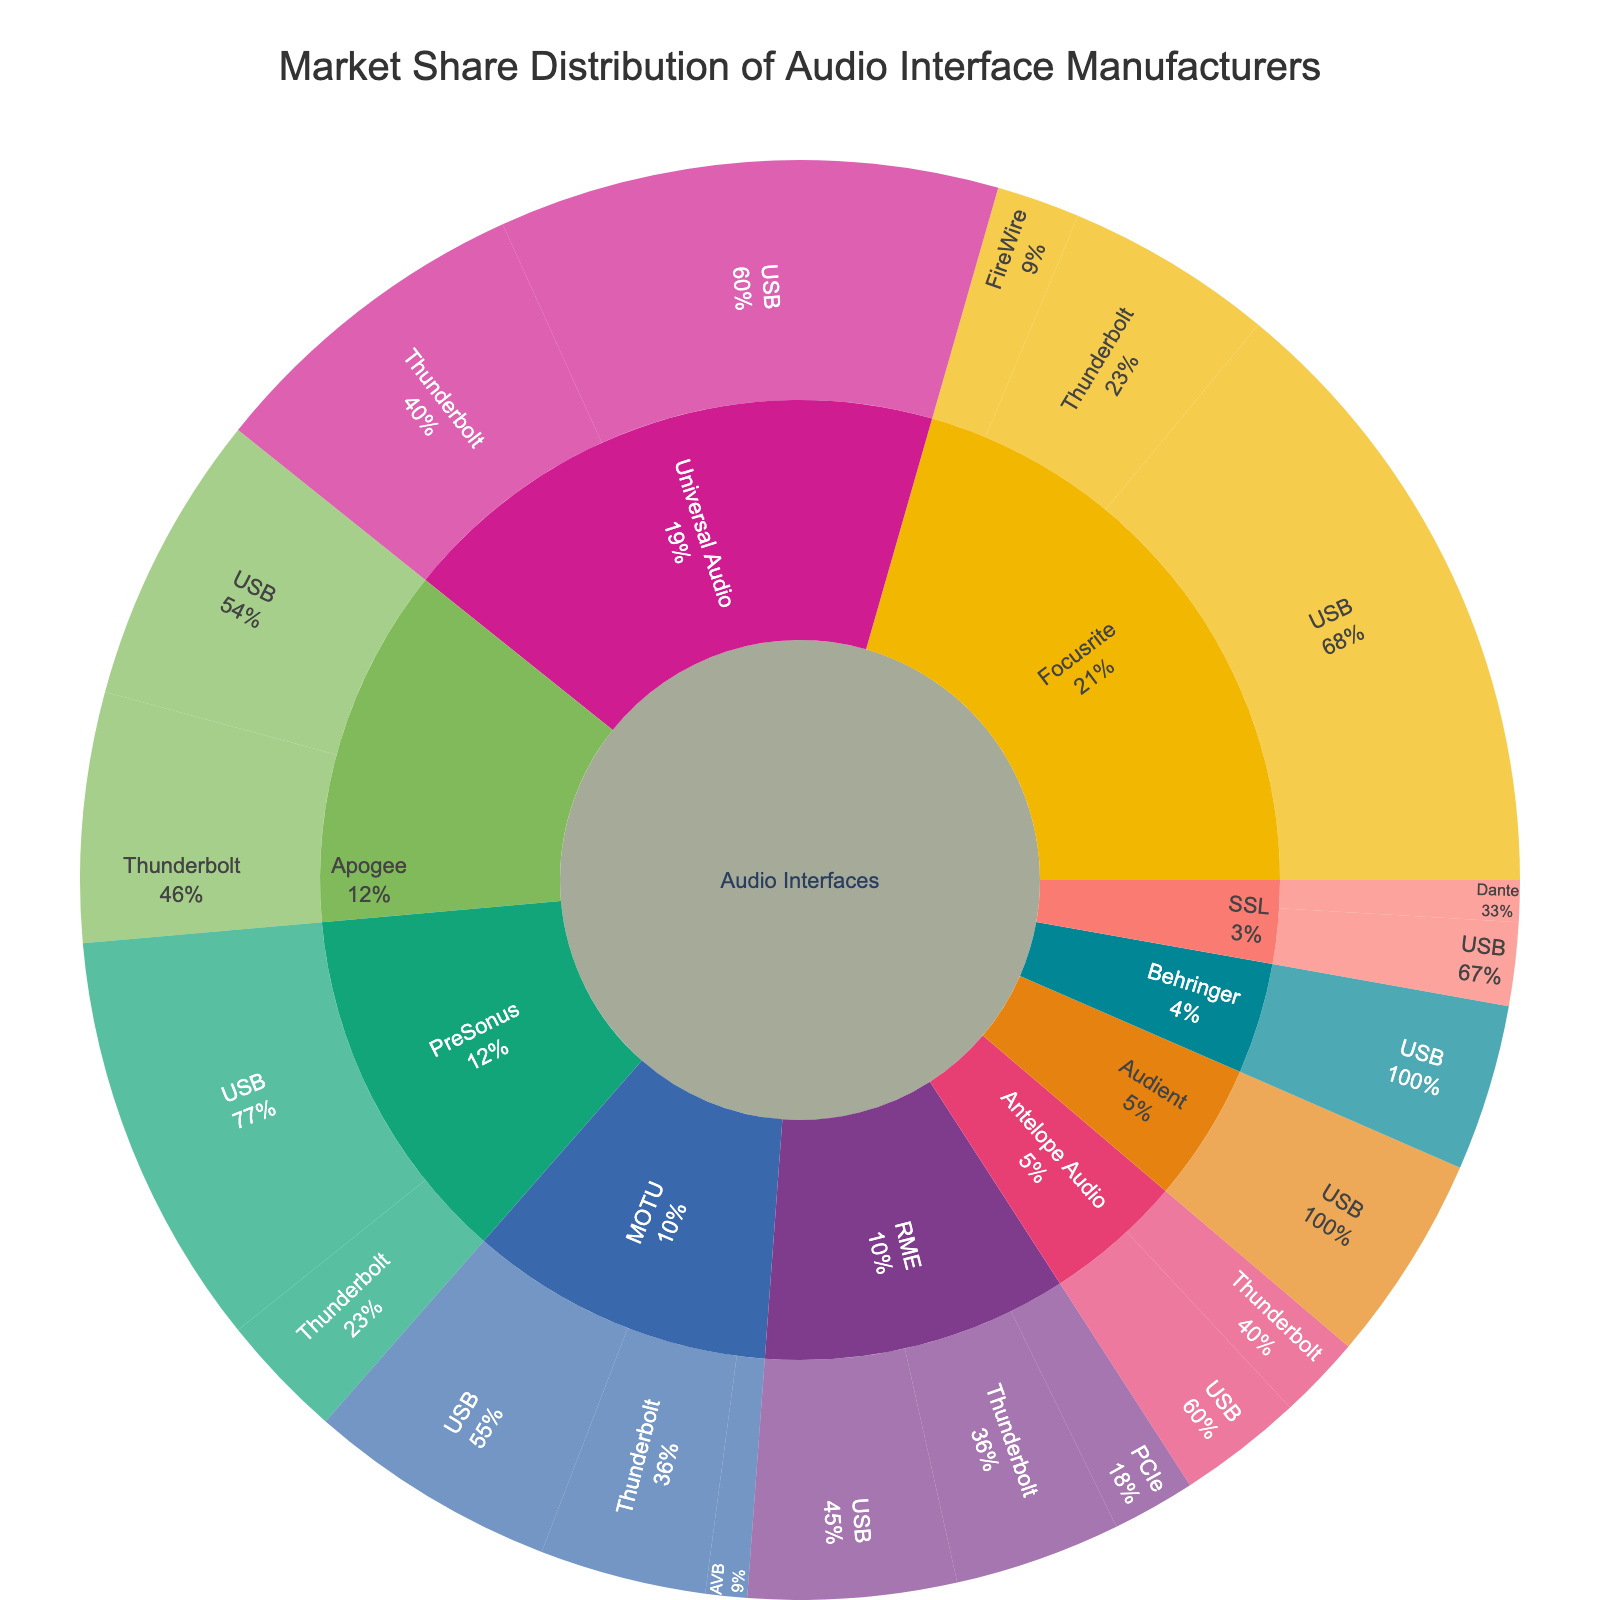What is the total market share for Universal Audio? Sum the market share values for Universal Audio across all connectivity types (USB and Thunderbolt): 12 + 8 = 20
Answer: 20 Which manufacturer has the highest market share for USB connectivity? Compare the market share values for USB connectivity across all manufacturers: Focusrite (15), Universal Audio (12), PreSonus (10), Apogee (7), RME (5), MOTU (6), Audient (5), Behringer (4), Antelope Audio (3), SSL (2). Focusrite has the highest value (15)
Answer: Focusrite How much more market share does Focusrite have with USB compared to Universal Audio's USB? Subtract the market share of Universal Audio (12) from Focusrite's market share (15) for USB: 15 - 12 = 3
Answer: 3 Which connectivity type has the lowest market share for MOTU? Compare the market share values for MOTU across all connectivity types (USB, Thunderbolt, AVB): AVB (1), Thunderbolt (4), USB (6). AVB has the lowest value (1)
Answer: AVB How does the market share of PreSonus with Thunderbolt compare to Apogee with USB? Compare the market share values: PreSonus with Thunderbolt (3) and Apogee with USB (7). Apogee with USB has a higher market share (7 versus 3)
Answer: Apogee with USB is higher What is the combined market share of RME for all its connectivity types? Sum the market share values for RME across all connectivity types (USB, Thunderbolt, PCIe): 5 + 4 + 2 = 11
Answer: 11 Which manufacturer has the least market share overall? Compare the total market share values for all manufacturers by summing their connectivity types, then identify the one with the smallest total:
- SSL: USB (2) + Dante (1) = 3
- Antelope Audio: USB (3) + Thunderbolt (2) = 5
- Behringer: USB (4)
- Audient: USB (5)
- MOTU: USB (6) + Thunderbolt (4) + AVB (1) = 11
- RME: USB (5) + Thunderbolt (4) + PCIe (2) = 11
- Apogee: USB (7) + Thunderbolt (6) = 13
- PreSonus: USB (10) + Thunderbolt (3) = 13
- Focusrite: USB (15) + Thunderbolt (5) + FireWire (2) = 22
- Universal Audio: USB (12) + Thunderbolt (8) = 20
SSL has the smallest total (3)
Answer: SSL What is the ratio of market share for USB versus Thunderbolt for all manufacturers combined? Sum the market shares for USB and Thunderbolt connectivity types for all manufacturers:
- USB total: 87 (Focusrite 15 + Universal Audio 12 + PreSonus 10 + Apogee 7 + RME 5 + MOTU 6 + Audient 5 + Behringer 4 + Antelope Audio 3 + SSL 2)
- Thunderbolt total: 32 (Focusrite 5 + Universal Audio 8 + PreSonus 3 + Apogee 6 + RME 4 + MOTU 4 + Antelope Audio 2)
- Ratio: 87/32 = 2.72
Answer: 2.72 Which is larger, the USB market share of Focusrite or the combined market share of all connectivity types of MOTU? Compare the values: Focusrite's USB market share is 15, MOTU's combined market share is 11 (USB 6 + Thunderbolt 4 + AVB 1). The USB market share of Focusrite (15) is larger than the combined market share of MOTU (11)
Answer: USB market share of Focusrite How does the market share of FireWire connectivity for Focusrite compare to the PCIe connectivity for RME? Compare the market share values: Focusrite's FireWire market share is 2, RME's PCIe market share is 2. Both have equal market share (2 versus 2)
Answer: Equal 